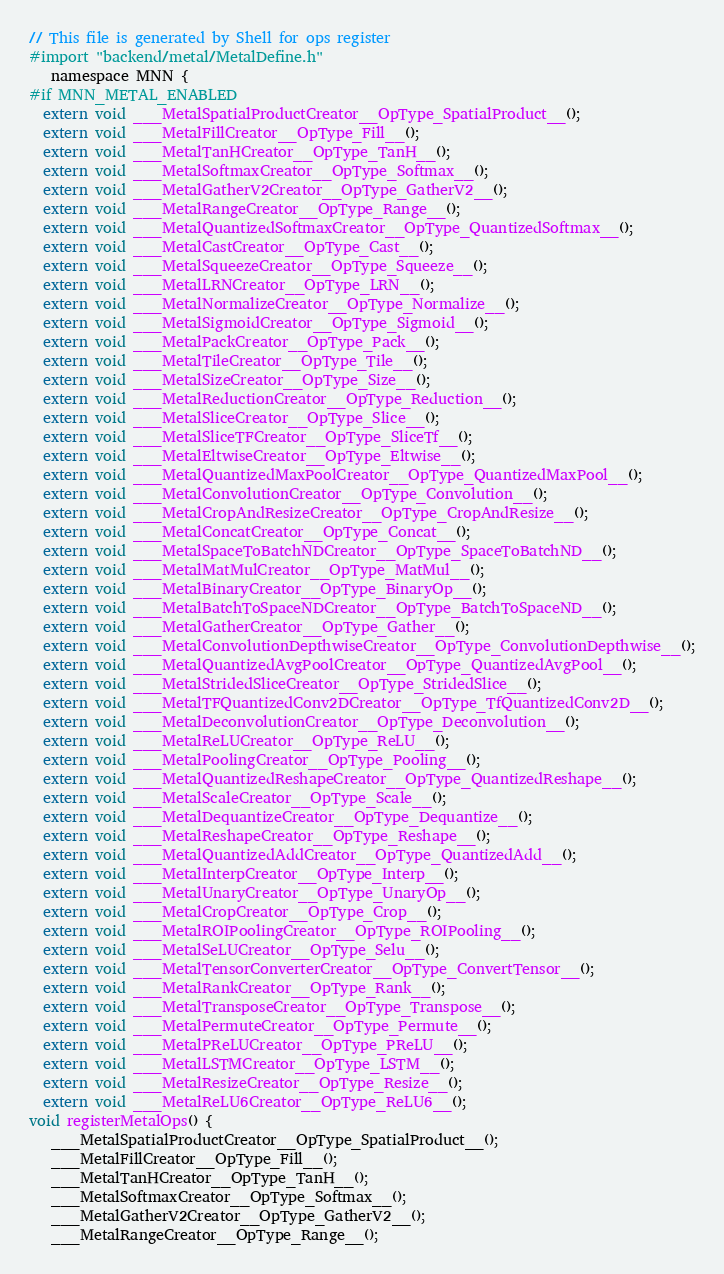<code> <loc_0><loc_0><loc_500><loc_500><_ObjectiveC_>// This file is generated by Shell for ops register
#import "backend/metal/MetalDefine.h"
   namespace MNN {
#if MNN_METAL_ENABLED
  extern void ___MetalSpatialProductCreator__OpType_SpatialProduct__();
  extern void ___MetalFillCreator__OpType_Fill__();
  extern void ___MetalTanHCreator__OpType_TanH__();
  extern void ___MetalSoftmaxCreator__OpType_Softmax__();
  extern void ___MetalGatherV2Creator__OpType_GatherV2__();
  extern void ___MetalRangeCreator__OpType_Range__();
  extern void ___MetalQuantizedSoftmaxCreator__OpType_QuantizedSoftmax__();
  extern void ___MetalCastCreator__OpType_Cast__();
  extern void ___MetalSqueezeCreator__OpType_Squeeze__();
  extern void ___MetalLRNCreator__OpType_LRN__();
  extern void ___MetalNormalizeCreator__OpType_Normalize__();
  extern void ___MetalSigmoidCreator__OpType_Sigmoid__();
  extern void ___MetalPackCreator__OpType_Pack__();
  extern void ___MetalTileCreator__OpType_Tile__();
  extern void ___MetalSizeCreator__OpType_Size__();
  extern void ___MetalReductionCreator__OpType_Reduction__();
  extern void ___MetalSliceCreator__OpType_Slice__();
  extern void ___MetalSliceTFCreator__OpType_SliceTf__();
  extern void ___MetalEltwiseCreator__OpType_Eltwise__();
  extern void ___MetalQuantizedMaxPoolCreator__OpType_QuantizedMaxPool__();
  extern void ___MetalConvolutionCreator__OpType_Convolution__();
  extern void ___MetalCropAndResizeCreator__OpType_CropAndResize__();
  extern void ___MetalConcatCreator__OpType_Concat__();
  extern void ___MetalSpaceToBatchNDCreator__OpType_SpaceToBatchND__();
  extern void ___MetalMatMulCreator__OpType_MatMul__();
  extern void ___MetalBinaryCreator__OpType_BinaryOp__();
  extern void ___MetalBatchToSpaceNDCreator__OpType_BatchToSpaceND__();
  extern void ___MetalGatherCreator__OpType_Gather__();
  extern void ___MetalConvolutionDepthwiseCreator__OpType_ConvolutionDepthwise__();
  extern void ___MetalQuantizedAvgPoolCreator__OpType_QuantizedAvgPool__();
  extern void ___MetalStridedSliceCreator__OpType_StridedSlice__();
  extern void ___MetalTFQuantizedConv2DCreator__OpType_TfQuantizedConv2D__();
  extern void ___MetalDeconvolutionCreator__OpType_Deconvolution__();
  extern void ___MetalReLUCreator__OpType_ReLU__();
  extern void ___MetalPoolingCreator__OpType_Pooling__();
  extern void ___MetalQuantizedReshapeCreator__OpType_QuantizedReshape__();
  extern void ___MetalScaleCreator__OpType_Scale__();
  extern void ___MetalDequantizeCreator__OpType_Dequantize__();
  extern void ___MetalReshapeCreator__OpType_Reshape__();
  extern void ___MetalQuantizedAddCreator__OpType_QuantizedAdd__();
  extern void ___MetalInterpCreator__OpType_Interp__();
  extern void ___MetalUnaryCreator__OpType_UnaryOp__();
  extern void ___MetalCropCreator__OpType_Crop__();
  extern void ___MetalROIPoolingCreator__OpType_ROIPooling__();
  extern void ___MetalSeLUCreator__OpType_Selu__();
  extern void ___MetalTensorConverterCreator__OpType_ConvertTensor__();
  extern void ___MetalRankCreator__OpType_Rank__();
  extern void ___MetalTransposeCreator__OpType_Transpose__();
  extern void ___MetalPermuteCreator__OpType_Permute__();
  extern void ___MetalPReLUCreator__OpType_PReLU__();
  extern void ___MetalLSTMCreator__OpType_LSTM__();
  extern void ___MetalResizeCreator__OpType_Resize__();
  extern void ___MetalReLU6Creator__OpType_ReLU6__();
void registerMetalOps() {
   ___MetalSpatialProductCreator__OpType_SpatialProduct__();
   ___MetalFillCreator__OpType_Fill__();
   ___MetalTanHCreator__OpType_TanH__();
   ___MetalSoftmaxCreator__OpType_Softmax__();
   ___MetalGatherV2Creator__OpType_GatherV2__();
   ___MetalRangeCreator__OpType_Range__();</code> 